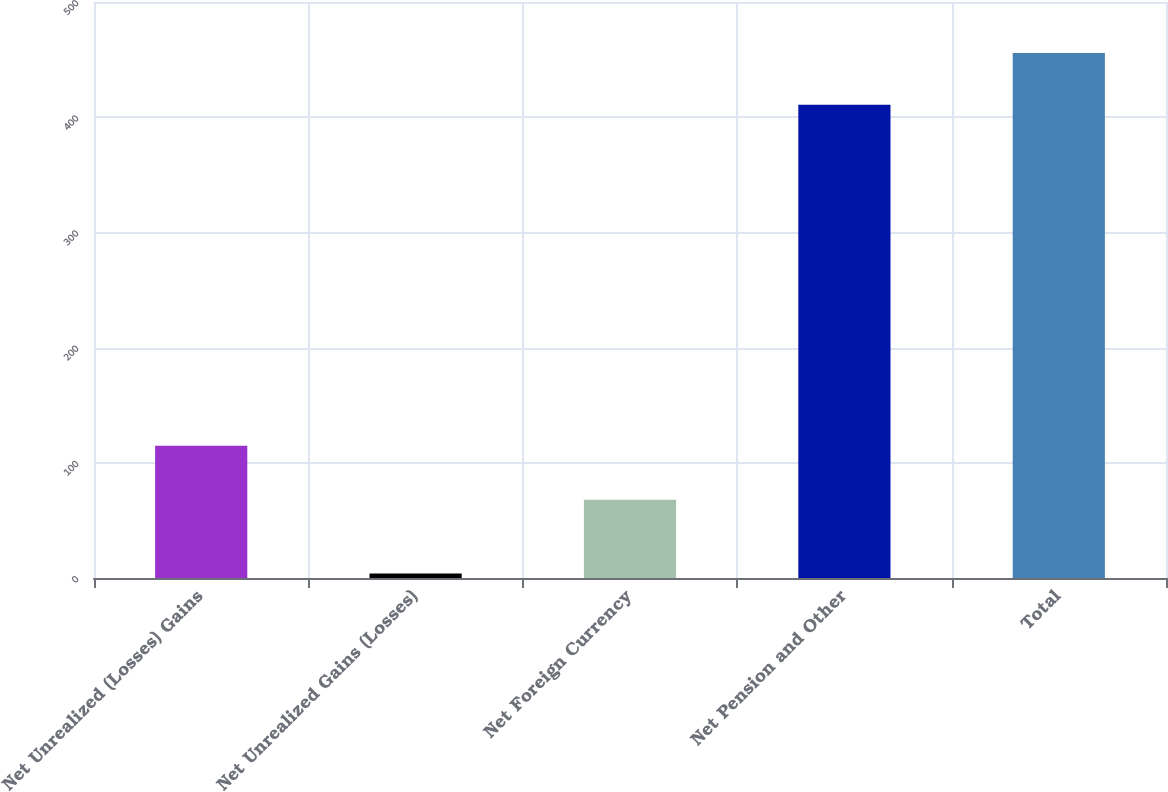Convert chart. <chart><loc_0><loc_0><loc_500><loc_500><bar_chart><fcel>Net Unrealized (Losses) Gains<fcel>Net Unrealized Gains (Losses)<fcel>Net Foreign Currency<fcel>Net Pension and Other<fcel>Total<nl><fcel>114.9<fcel>4<fcel>67.9<fcel>410.7<fcel>455.67<nl></chart> 